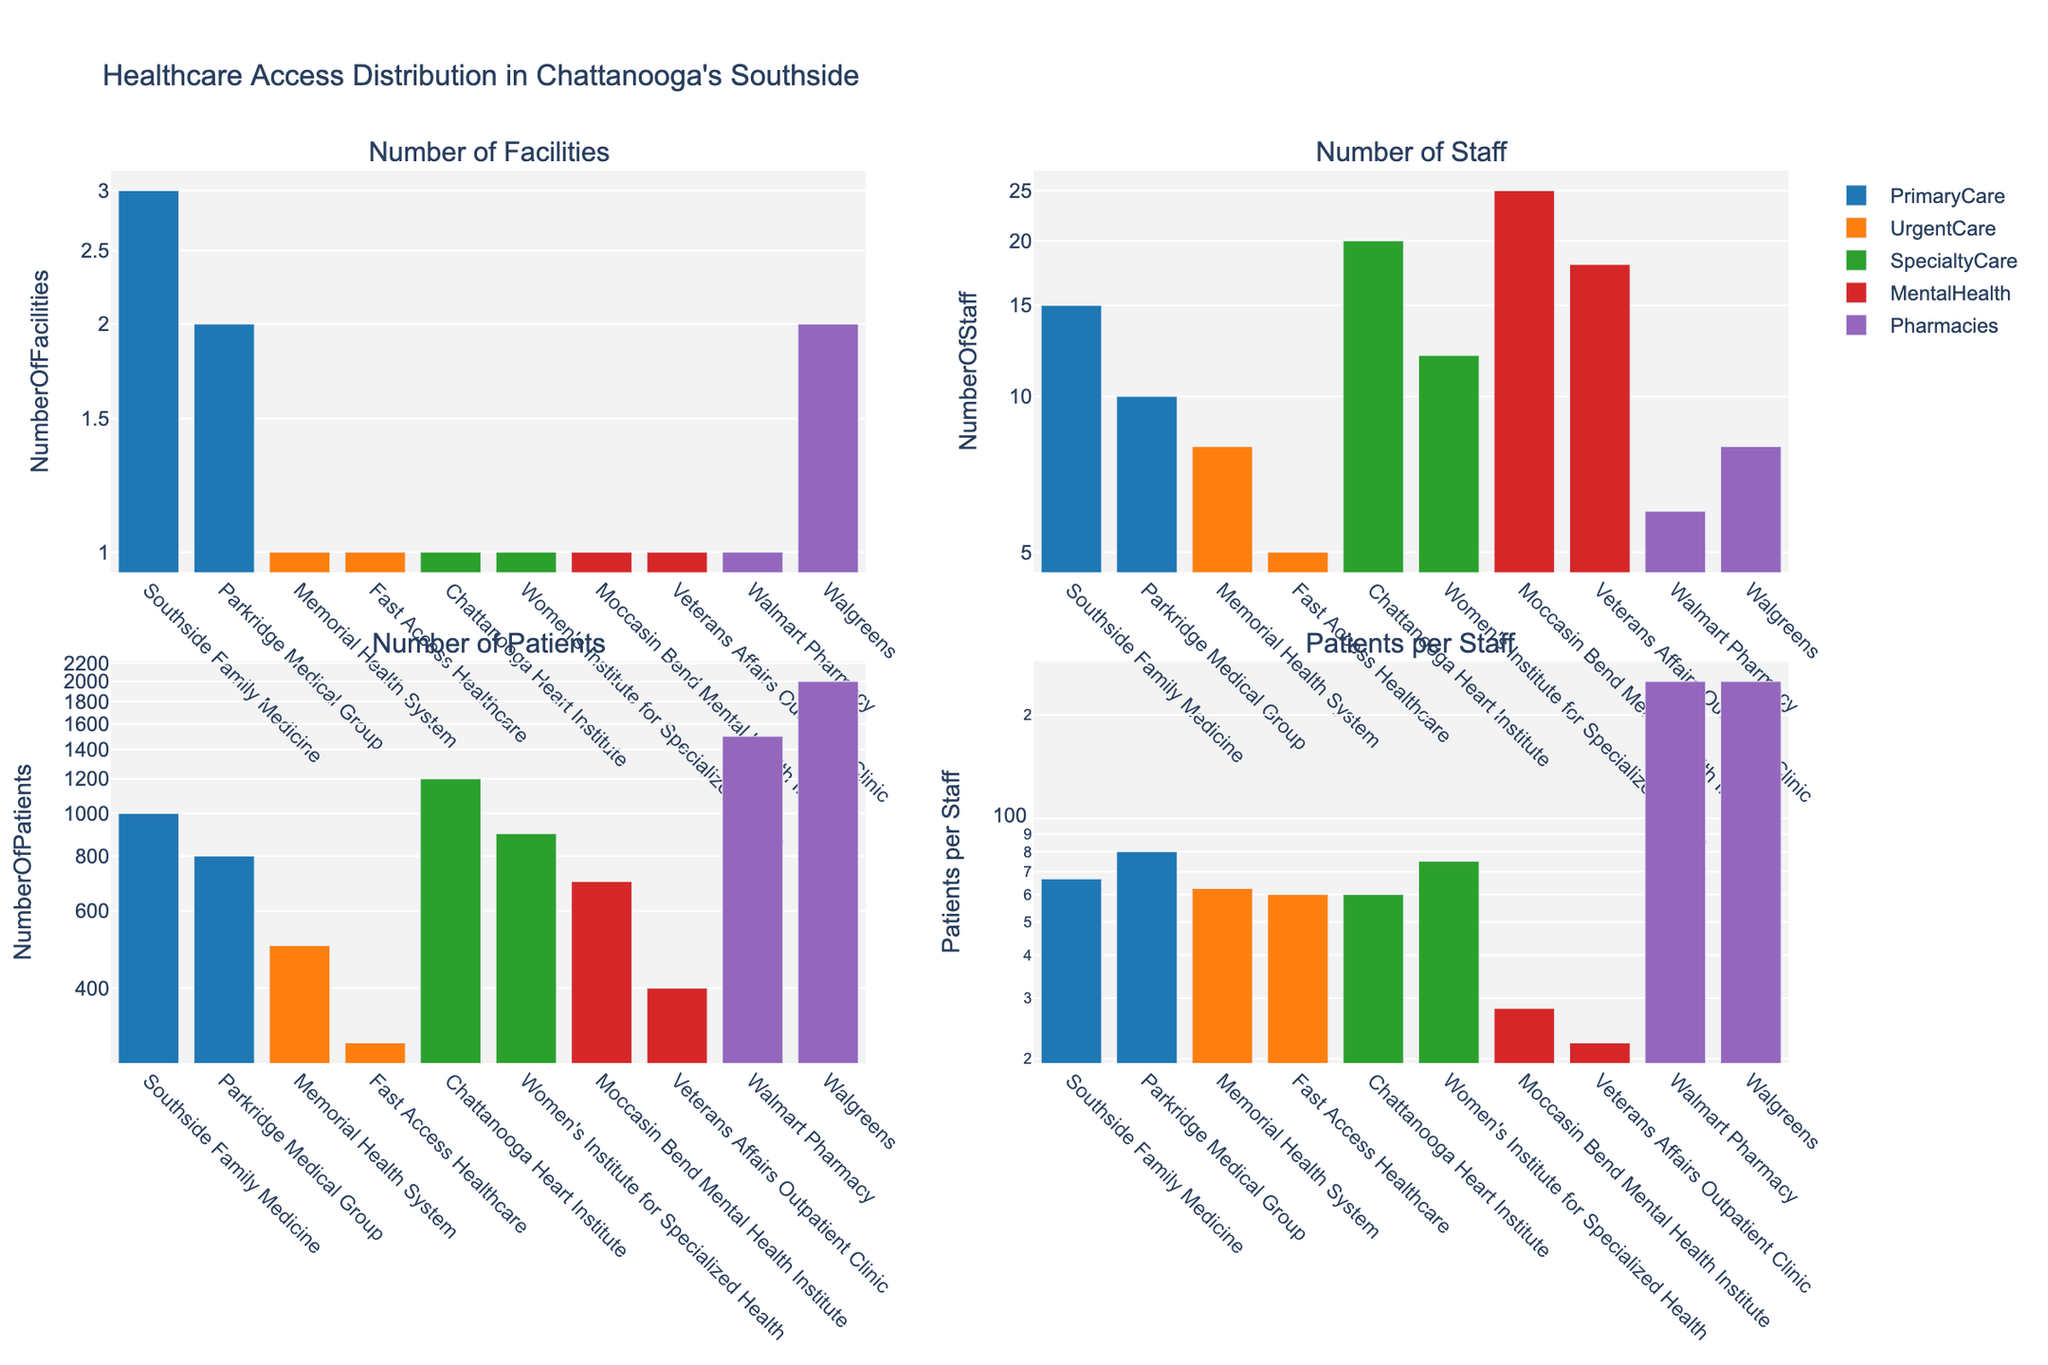What is the title of the figure? The title of the figure is typically located at the top. For this figure, it is placed above the subplots.
Answer: Healthcare Access Distribution in Chattanooga's Southside How many types of healthcare services are represented in the figure? Count the unique categories or legends shown. The legend includes Primary Care, Urgent Care, Specialty Care, Mental Health, and Pharmacies.
Answer: 5 Which location has the highest number of facilities for Primary Care? Look at the 'Number of Facilities' subplot and focus on the bars representing Primary Care. Compare the bar heights for "Southside Family Medicine" and "Parkridge Medical Group."
Answer: Southside Family Medicine What is the number of patients per staff for Veterans Affairs Outpatient Clinic? Find the "Veterans Affairs Outpatient Clinic" in the 'Patients per Staff' subplot. Read the corresponding bar's height which represents the value on a log scale.
Answer: ~22.22 Which type of healthcare service has the fewest facilities in total? Add the number of facilities for all locations under each service type. Compare the totals.
Answer: Urgent Care Are there more staff in Specialty Care or in Primary Care? Sum the number of staff for all locations within each service. Compare the totals for Primary Care (3+2 locations) and Specialty Care (2 locations).
Answer: Specialty Care What is the approximate patients-to-staff ratio for Southside Family Medicine? Use the 'Patients per Staff' subplot. For "Southside Family Medicine," read the bar's height and visualize the value on the log scale.
Answer: ~66.67 Which pharmacy has more patients? Look at the 'Number of Patients' subplot and compare the bar heights for "Walmart Pharmacy" and "Walgreens."
Answer: Walgreens Which healthcare service has the most patients on average? Calculate the average number of patients for each service type. For each type, sum the number of patients from all locations and divide by the number of locations. Compare averages.
Answer: Specialty Care Is the number of staff at Moccasin Bend Mental Health Institute greater than or equal to the total staff at all Urgent Care facilities? Look at the 'Number of Staff' subplot. Sum the staff for Urgent Care (Memorial Health System and Fast Access Healthcare) and compare it with the staff at Moccasin Bend.
Answer: Yes 